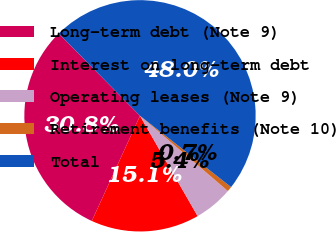Convert chart to OTSL. <chart><loc_0><loc_0><loc_500><loc_500><pie_chart><fcel>Long-term debt (Note 9)<fcel>Interest on long-term debt<fcel>Operating leases (Note 9)<fcel>Retirement benefits (Note 10)<fcel>Total<nl><fcel>30.76%<fcel>15.14%<fcel>5.43%<fcel>0.7%<fcel>47.97%<nl></chart> 